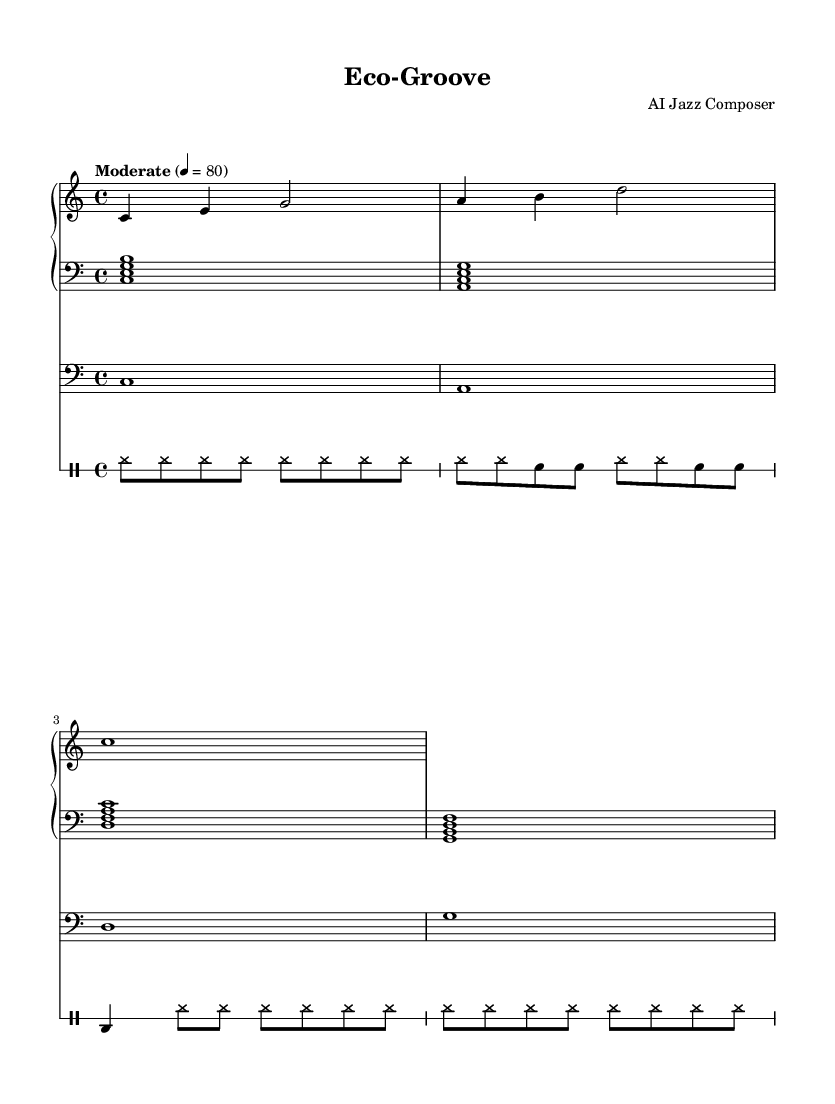What is the time signature of this music? The time signature is indicated at the beginning of the score and is written as "4/4". This means there are four beats in each measure, and each quarter note gets one beat.
Answer: 4/4 What is the tempo marking for this piece? The tempo marking is found near the top of the score where it states "Moderate" followed by 4 = 80. This indicates the speed of the piece, suggesting a moderate pace at 80 beats per minute.
Answer: Moderate What is the key signature of this music? The key signature is C major, which is shown by the absence of any sharps or flats at the beginning of the staff. This means the piece will primarily use the white keys on the piano.
Answer: C major How many measures are in the drum part? By examining the drum part, I can count the number of measures present. Each line in the drum notation is separated by a bar line, and there are four distinct sections across the notation.
Answer: 4 What is the root note of the first chord in the left hand? Looking at the left-hand part of the piano, the first chord is marked with the notes C, E, and G which form a C major chord. The root note here is the lowest note in the chord.
Answer: C What kind of textures are prevalent in the arrangement? The score displays sparse arrangements, characterized by minimalist parts for each instrument, particularly in the piano left-hand, which contrasts with richer textures typical in other jazz pieces. This allows for more subtle interplay between the musicians.
Answer: Sparse How many different instruments are represented in this score? By analyzing the score, there are clear indications of three distinct parts: the piano (with both right and left hand), a bass part, and a drum part. Therefore, a total of three different instruments are included.
Answer: 3 